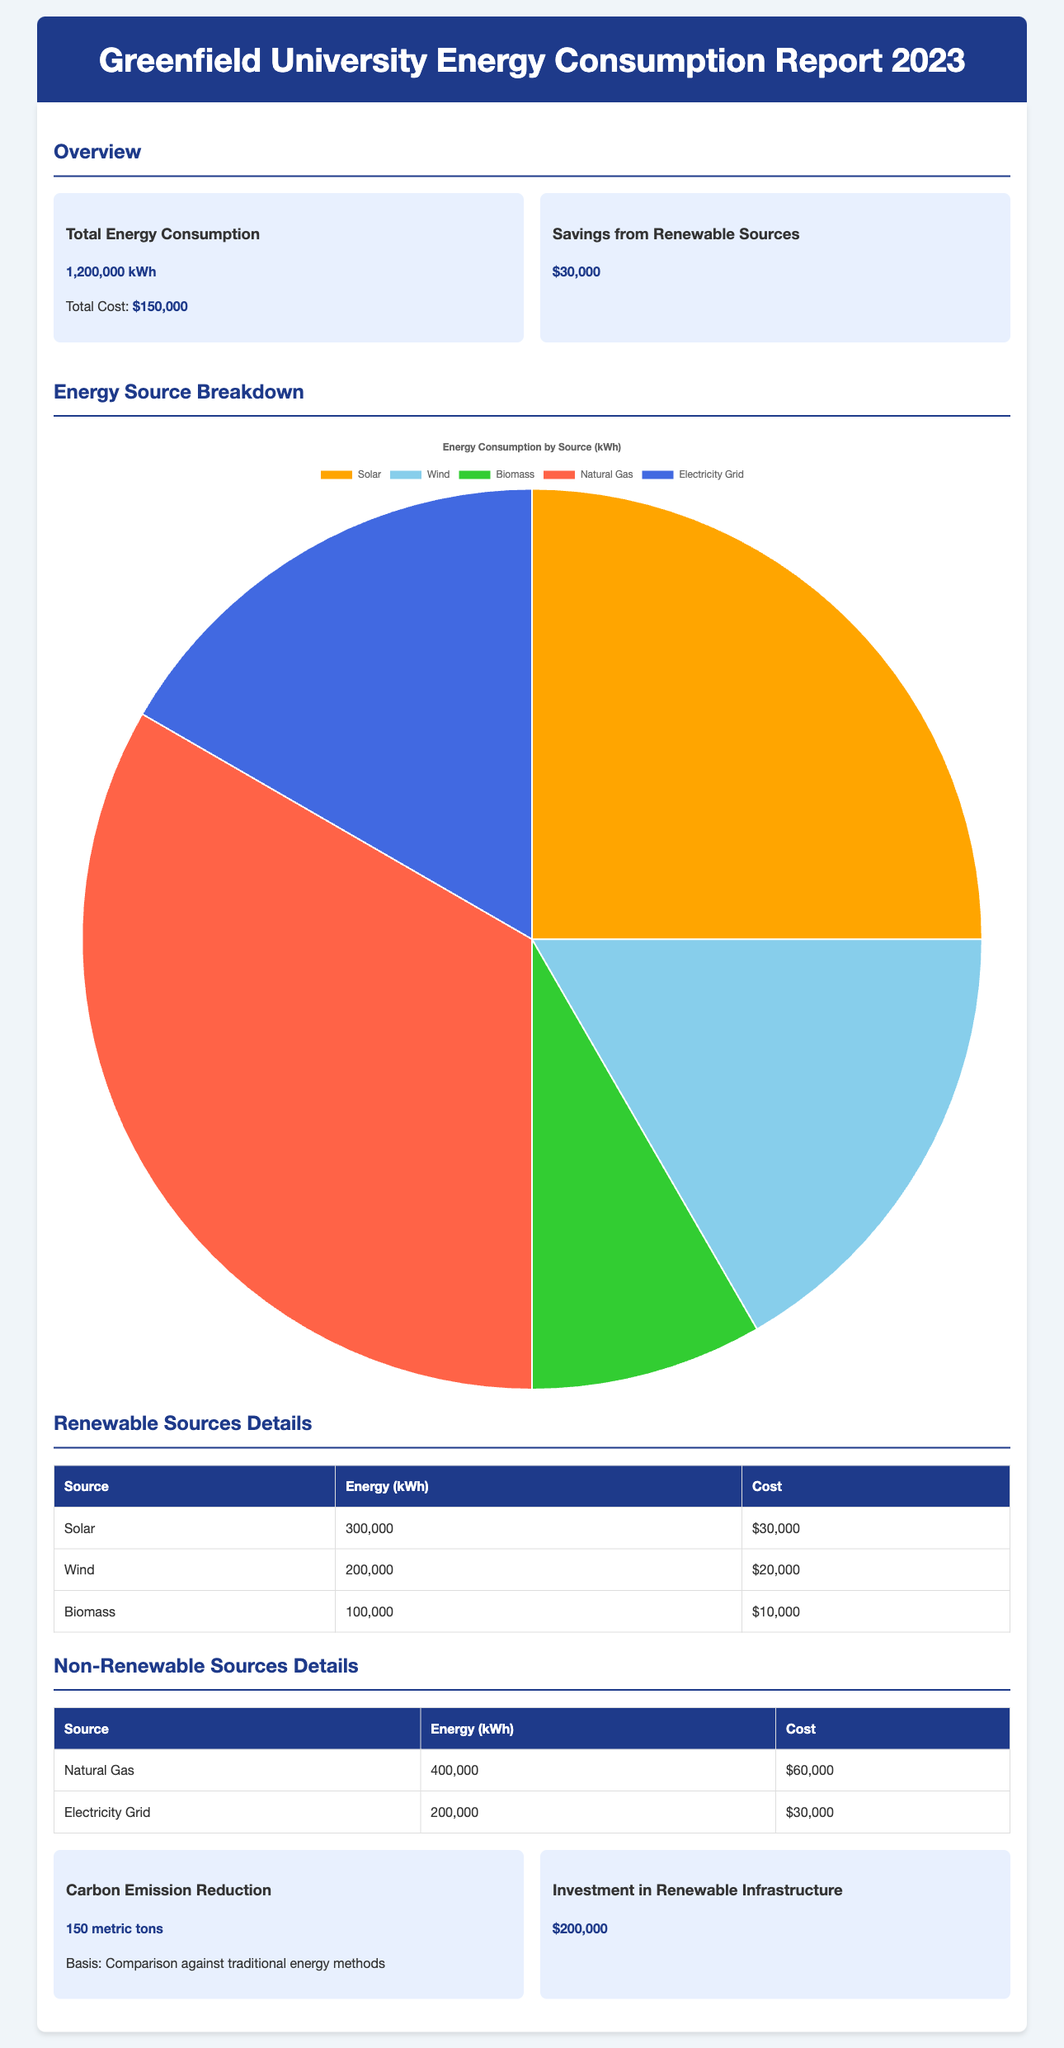What is the total energy consumption? The total energy consumption is explicitly stated in the document, which is 1,200,000 kWh.
Answer: 1,200,000 kWh What is the total cost of energy consumption? The total cost is provided in the overview section of the document, which sums up to $150,000.
Answer: $150,000 How much savings are reported from renewable sources? The savings derived from renewable sources is mentioned in the document, which totals to $30,000.
Answer: $30,000 What is the energy consumption from solar energy? The document specifies that solar energy contributed 300,000 kWh to the total energy consumption.
Answer: 300,000 kWh What is the total cost of non-renewable sources? The total cost can be calculated from the listed costs for non-renewable sources, which sums up to $90,000 ($60,000 + $30,000).
Answer: $90,000 How many metric tons of carbon emission reduction were achieved? The report states that 150 metric tons of carbon emissions were reduced, based on a comparison against traditional energy methods.
Answer: 150 metric tons What was the investment in renewable infrastructure? The investment targeted towards renewable infrastructure is detailed in the report, which amounts to $200,000.
Answer: $200,000 Which renewable source contributed the least energy? The renewable source that contributed the least energy is biomass at 100,000 kWh.
Answer: Biomass What was the share of wind energy in the total energy consumption? The wind energy share is calculated as 200,000 kWh, which reflects its contribution within the total consumption figures presented.
Answer: 200,000 kWh 